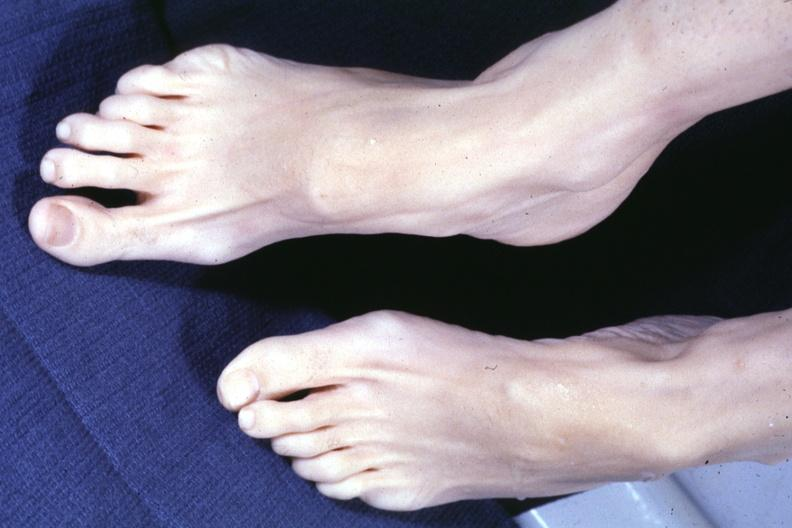does this image show both feet with aortic dissection and mitral prolapse extremities which suggest marfans?
Answer the question using a single word or phrase. Yes 